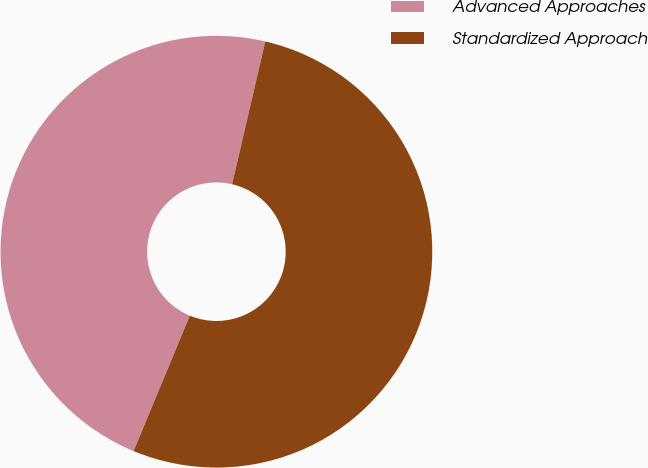<chart> <loc_0><loc_0><loc_500><loc_500><pie_chart><fcel>Advanced Approaches<fcel>Standardized Approach<nl><fcel>47.37%<fcel>52.63%<nl></chart> 